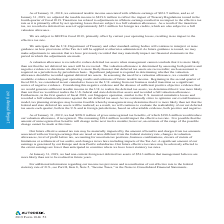According to Autodesk's financial document, Why was there less interest and other expense in 2019 compared to 2018? Based on the financial document, the answer is primarily driven by curtailment gains on our pension plans, mark-to-market gains on certain of our privately-held strategic investments, realized gains on sales of strategic investments, offset by an increase in interest expense resulting from our term loan entered into on December 17, 2018 in aggregate principal amount of $500 million and mark-to-market losses on marketable securities.. Also, can you calculate: What is average "other income" for the 3 year period from 2017 to 2019? To answer this question, I need to perform calculations using the financial data. The calculation is: (16.8 + 6.0 + 8.5) / 3 , which equals 10.43 (in millions). The key data points involved are: 16.8, 6.0, 8.5. Also, Why was there a loss in strategic investments in 2018 compared to 2017? Based on the financial document, the answer is Impairment losses. Also, can you calculate: How much did net interest and investment expense increase over fiscal year ending January 31, 2019? To answer this question, I need to perform calculations using the financial data. The calculation is: (52.1-34.5)/34.5 , which equals 51.01 (percentage). The key data points involved are: 34.5, 52.1. Also, What determines the amount of gain or loss on the foreign currency? Based on the financial document, the answer is volume of foreign currency transactions and the foreign currency exchange rates for the year. Also, can you calculate: What is the total net interest and other expenses for all 3 years? Based on the calculation: 17.7+48.2+24.2, the result is 90.1 (in millions). The key data points involved are: 17.7, 24.2, 48.2. 